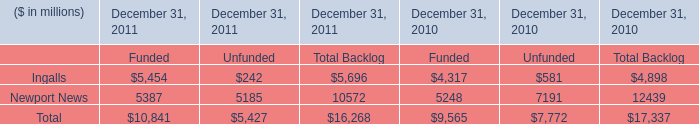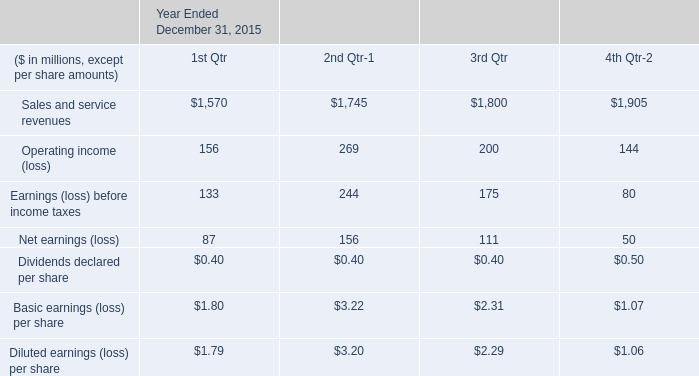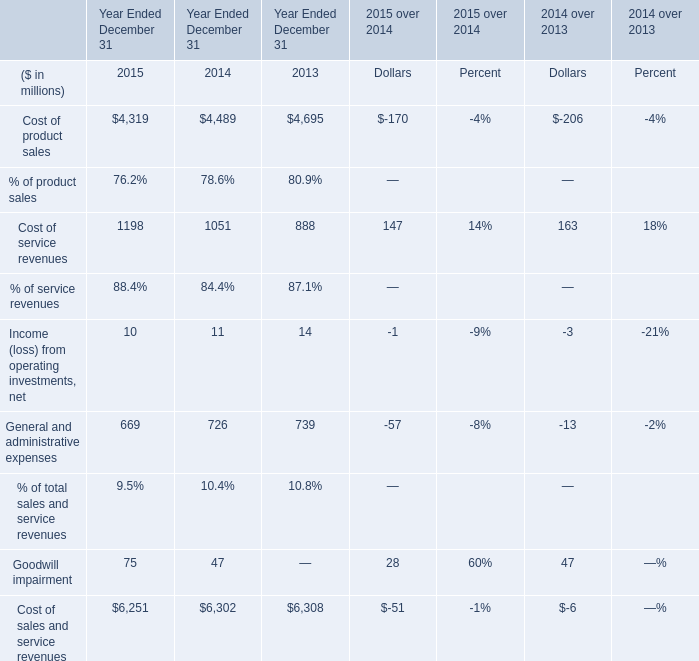What's the sum of Ingalls of December 31, 2010 Funded, and Cost of product sales of Year Ended December 31 2013 ? 
Computations: (4317.0 + 4695.0)
Answer: 9012.0. 